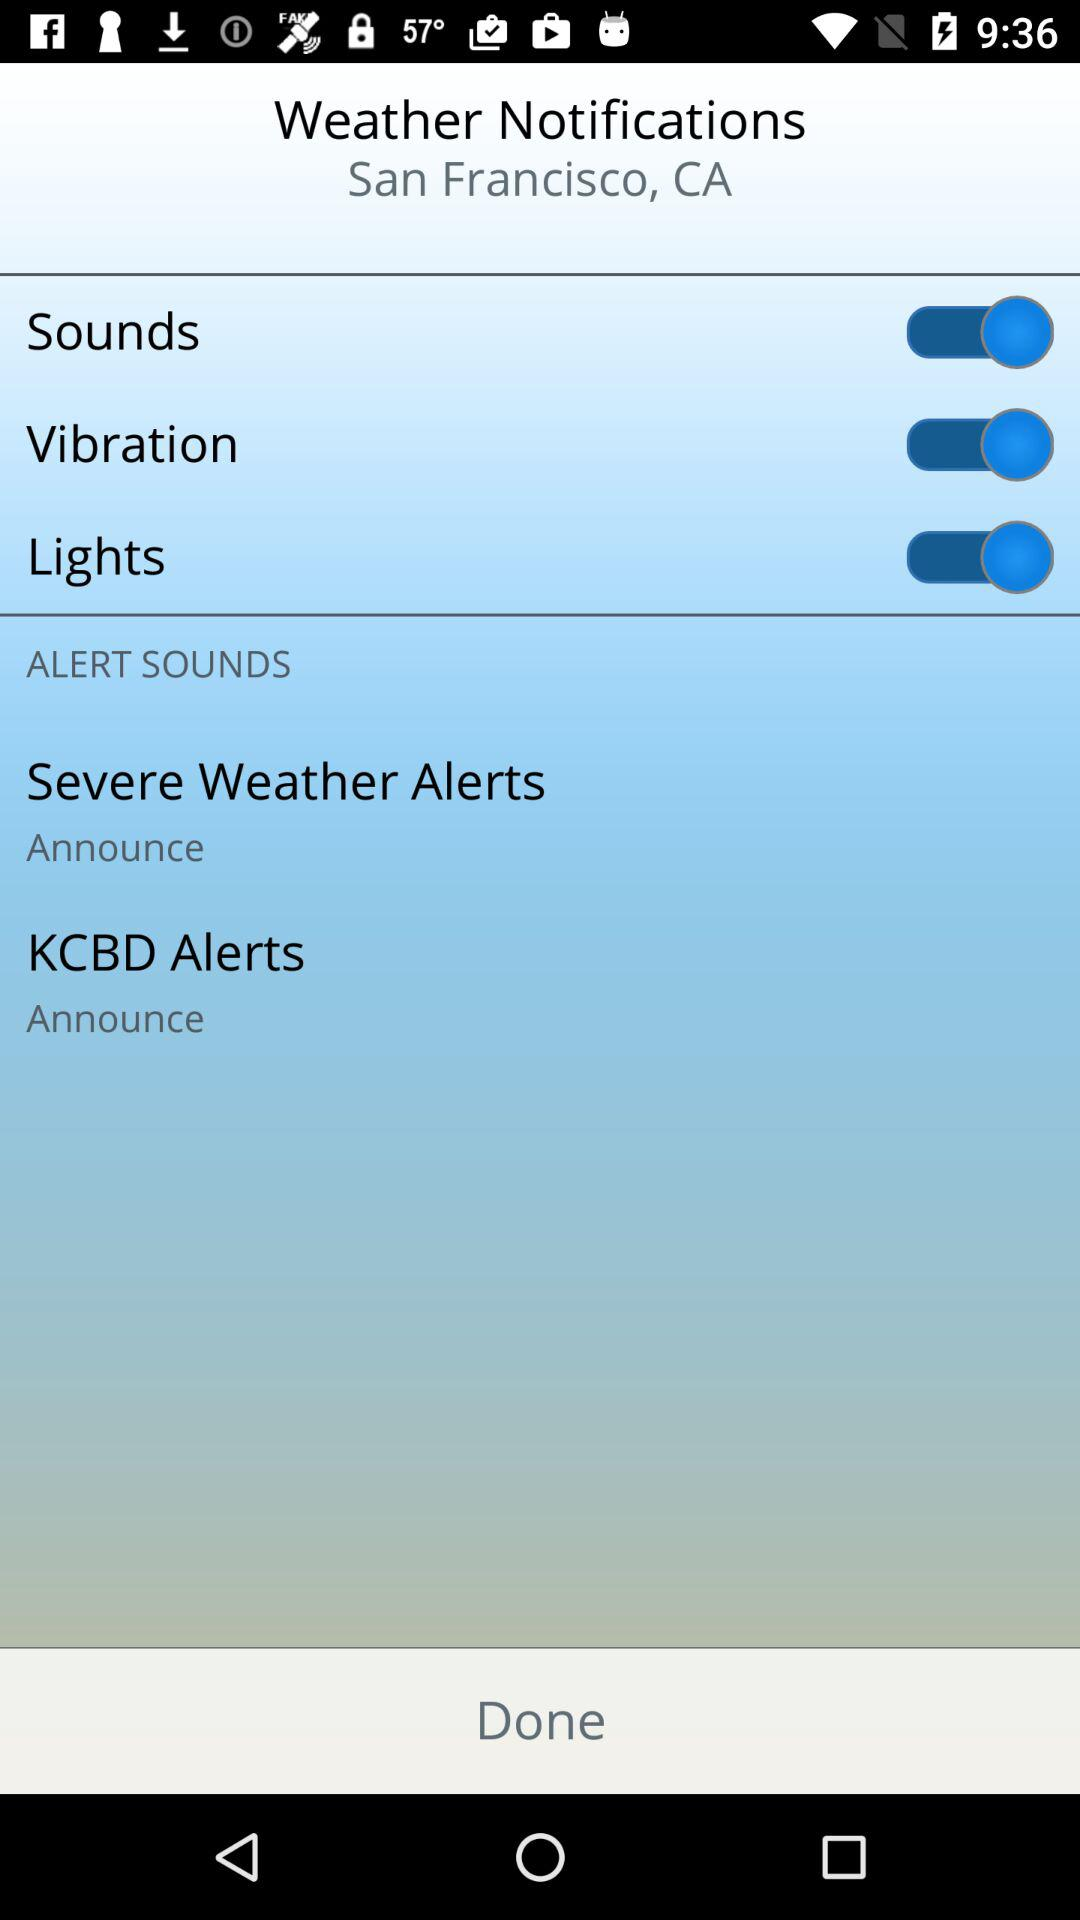What is the status of "Sounds"? The status of "Sounds" is "on". 